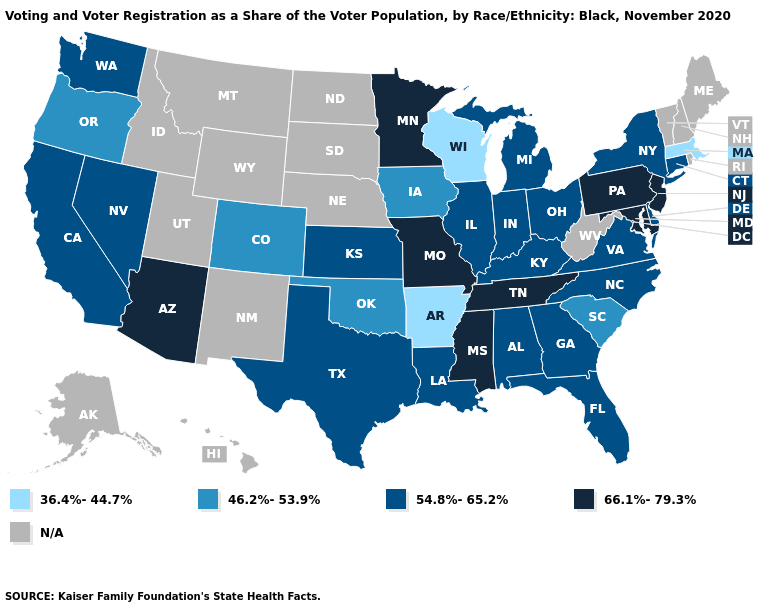Does Massachusetts have the highest value in the Northeast?
Give a very brief answer. No. Does the first symbol in the legend represent the smallest category?
Keep it brief. Yes. Does Ohio have the highest value in the USA?
Keep it brief. No. Among the states that border New Jersey , which have the highest value?
Keep it brief. Pennsylvania. Is the legend a continuous bar?
Short answer required. No. Among the states that border Kentucky , which have the lowest value?
Write a very short answer. Illinois, Indiana, Ohio, Virginia. Does Missouri have the highest value in the MidWest?
Answer briefly. Yes. What is the lowest value in the USA?
Be succinct. 36.4%-44.7%. Which states have the highest value in the USA?
Keep it brief. Arizona, Maryland, Minnesota, Mississippi, Missouri, New Jersey, Pennsylvania, Tennessee. Among the states that border Tennessee , which have the lowest value?
Keep it brief. Arkansas. What is the value of Colorado?
Be succinct. 46.2%-53.9%. Does Connecticut have the highest value in the Northeast?
Concise answer only. No. Does the first symbol in the legend represent the smallest category?
Give a very brief answer. Yes. Name the states that have a value in the range 36.4%-44.7%?
Quick response, please. Arkansas, Massachusetts, Wisconsin. 